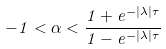<formula> <loc_0><loc_0><loc_500><loc_500>- 1 < \alpha < \frac { 1 + e ^ { - | \lambda | \tau } } { 1 - e ^ { - | \lambda | \tau } }</formula> 